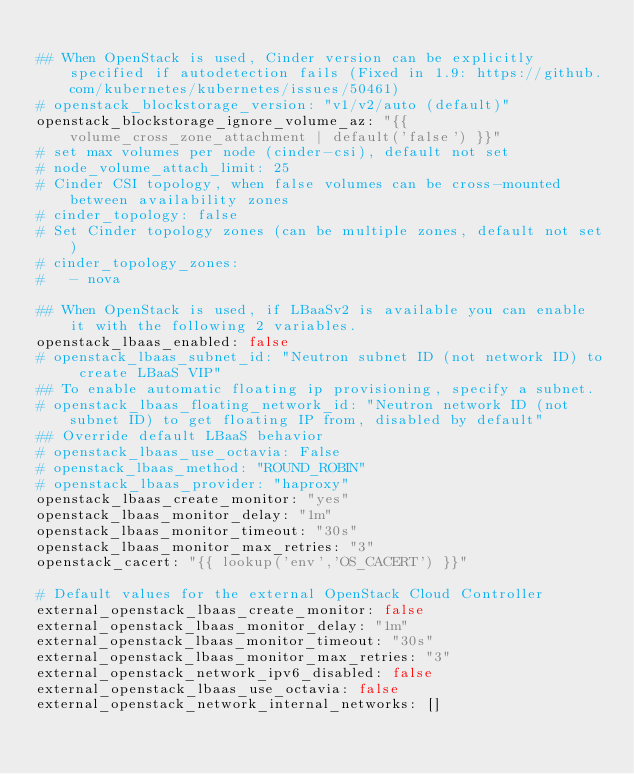Convert code to text. <code><loc_0><loc_0><loc_500><loc_500><_YAML_>
## When OpenStack is used, Cinder version can be explicitly specified if autodetection fails (Fixed in 1.9: https://github.com/kubernetes/kubernetes/issues/50461)
# openstack_blockstorage_version: "v1/v2/auto (default)"
openstack_blockstorage_ignore_volume_az: "{{ volume_cross_zone_attachment | default('false') }}"
# set max volumes per node (cinder-csi), default not set
# node_volume_attach_limit: 25
# Cinder CSI topology, when false volumes can be cross-mounted between availability zones
# cinder_topology: false
# Set Cinder topology zones (can be multiple zones, default not set)
# cinder_topology_zones:
#   - nova

## When OpenStack is used, if LBaaSv2 is available you can enable it with the following 2 variables.
openstack_lbaas_enabled: false
# openstack_lbaas_subnet_id: "Neutron subnet ID (not network ID) to create LBaaS VIP"
## To enable automatic floating ip provisioning, specify a subnet.
# openstack_lbaas_floating_network_id: "Neutron network ID (not subnet ID) to get floating IP from, disabled by default"
## Override default LBaaS behavior
# openstack_lbaas_use_octavia: False
# openstack_lbaas_method: "ROUND_ROBIN"
# openstack_lbaas_provider: "haproxy"
openstack_lbaas_create_monitor: "yes"
openstack_lbaas_monitor_delay: "1m"
openstack_lbaas_monitor_timeout: "30s"
openstack_lbaas_monitor_max_retries: "3"
openstack_cacert: "{{ lookup('env','OS_CACERT') }}"

# Default values for the external OpenStack Cloud Controller
external_openstack_lbaas_create_monitor: false
external_openstack_lbaas_monitor_delay: "1m"
external_openstack_lbaas_monitor_timeout: "30s"
external_openstack_lbaas_monitor_max_retries: "3"
external_openstack_network_ipv6_disabled: false
external_openstack_lbaas_use_octavia: false
external_openstack_network_internal_networks: []</code> 